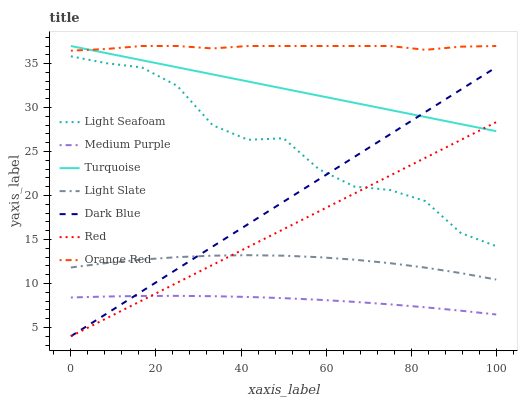Does Medium Purple have the minimum area under the curve?
Answer yes or no. Yes. Does Orange Red have the maximum area under the curve?
Answer yes or no. Yes. Does Light Slate have the minimum area under the curve?
Answer yes or no. No. Does Light Slate have the maximum area under the curve?
Answer yes or no. No. Is Red the smoothest?
Answer yes or no. Yes. Is Light Seafoam the roughest?
Answer yes or no. Yes. Is Light Slate the smoothest?
Answer yes or no. No. Is Light Slate the roughest?
Answer yes or no. No. Does Light Slate have the lowest value?
Answer yes or no. No. Does Light Slate have the highest value?
Answer yes or no. No. Is Medium Purple less than Light Seafoam?
Answer yes or no. Yes. Is Orange Red greater than Medium Purple?
Answer yes or no. Yes. Does Medium Purple intersect Light Seafoam?
Answer yes or no. No. 